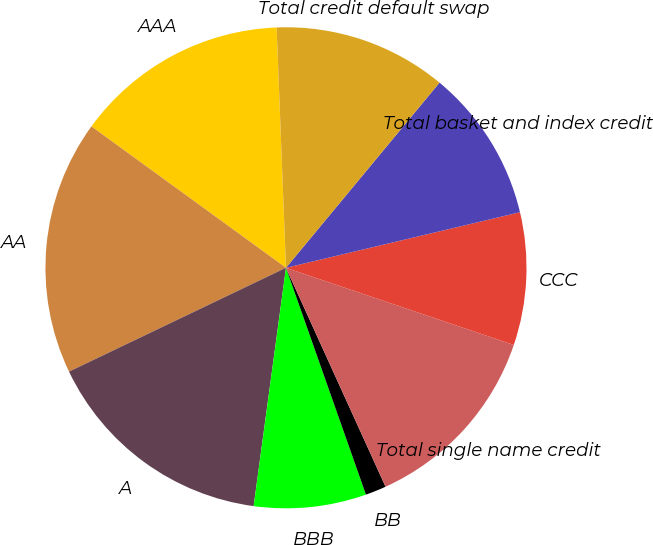Convert chart to OTSL. <chart><loc_0><loc_0><loc_500><loc_500><pie_chart><fcel>AAA<fcel>AA<fcel>A<fcel>BBB<fcel>BB<fcel>Total single name credit<fcel>CCC<fcel>Total basket and index credit<fcel>Total credit default swap<nl><fcel>14.38%<fcel>17.11%<fcel>15.75%<fcel>7.54%<fcel>1.4%<fcel>13.01%<fcel>8.91%<fcel>10.27%<fcel>11.64%<nl></chart> 